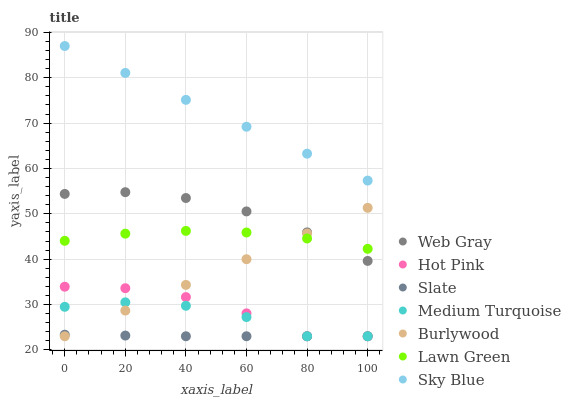Does Slate have the minimum area under the curve?
Answer yes or no. Yes. Does Sky Blue have the maximum area under the curve?
Answer yes or no. Yes. Does Web Gray have the minimum area under the curve?
Answer yes or no. No. Does Web Gray have the maximum area under the curve?
Answer yes or no. No. Is Burlywood the smoothest?
Answer yes or no. Yes. Is Hot Pink the roughest?
Answer yes or no. Yes. Is Web Gray the smoothest?
Answer yes or no. No. Is Web Gray the roughest?
Answer yes or no. No. Does Burlywood have the lowest value?
Answer yes or no. Yes. Does Web Gray have the lowest value?
Answer yes or no. No. Does Sky Blue have the highest value?
Answer yes or no. Yes. Does Web Gray have the highest value?
Answer yes or no. No. Is Burlywood less than Sky Blue?
Answer yes or no. Yes. Is Web Gray greater than Hot Pink?
Answer yes or no. Yes. Does Burlywood intersect Slate?
Answer yes or no. Yes. Is Burlywood less than Slate?
Answer yes or no. No. Is Burlywood greater than Slate?
Answer yes or no. No. Does Burlywood intersect Sky Blue?
Answer yes or no. No. 